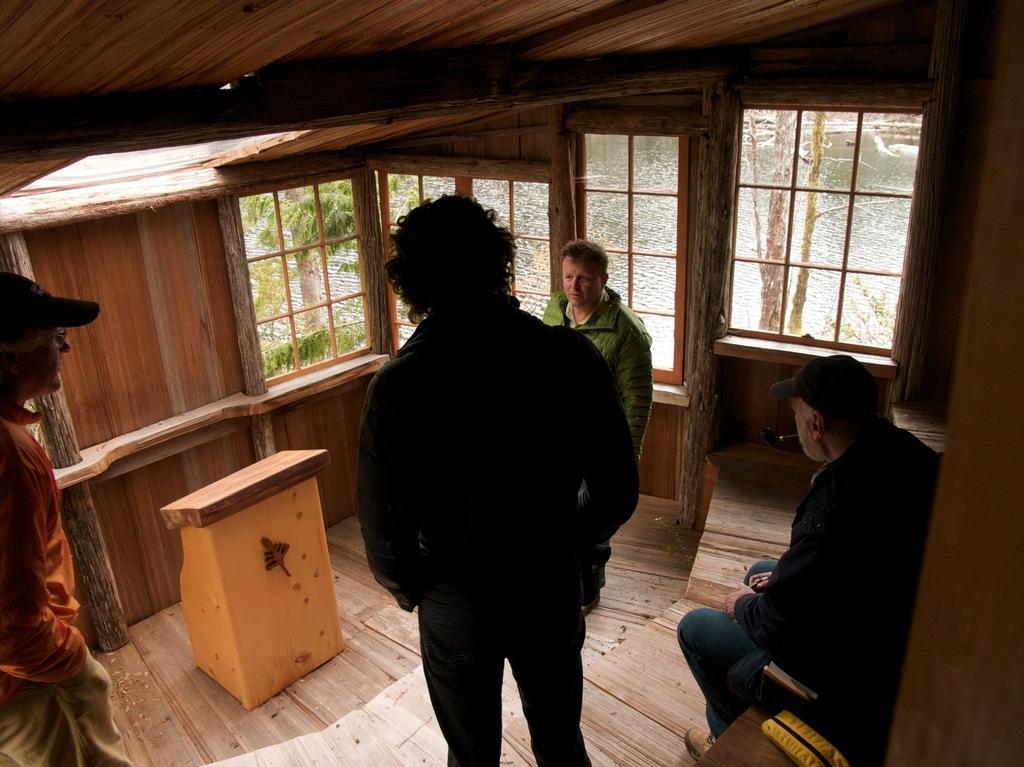Could you give a brief overview of what you see in this image? The image is taken in a wooden house. In this picture there are men talking. In the center of the picture there are windows, outside the windows there are trees and a water body. On the left there is podium. 